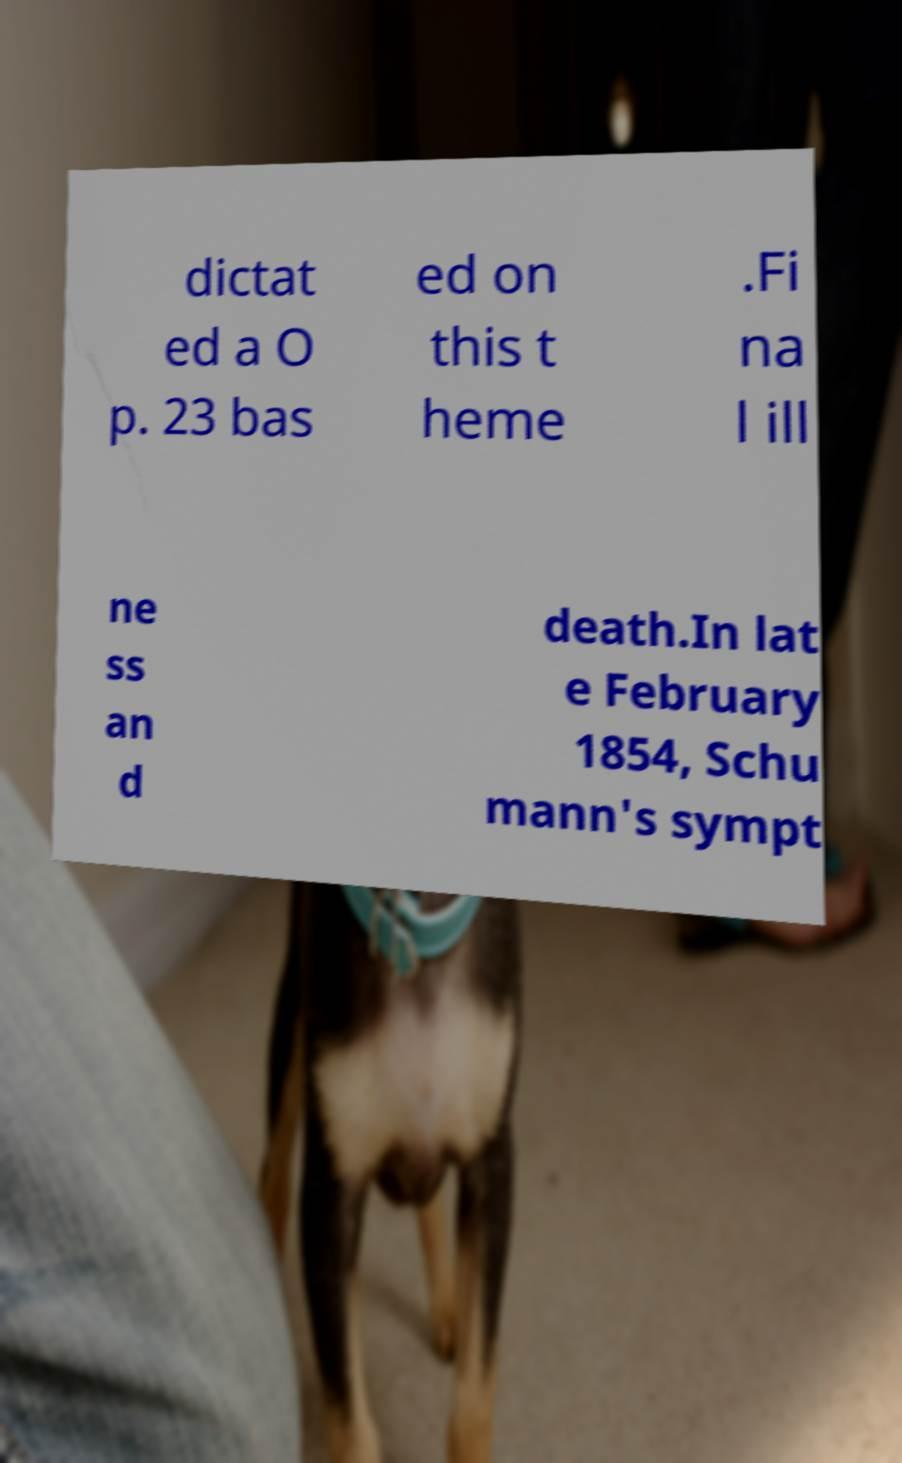What messages or text are displayed in this image? I need them in a readable, typed format. dictat ed a O p. 23 bas ed on this t heme .Fi na l ill ne ss an d death.In lat e February 1854, Schu mann's sympt 